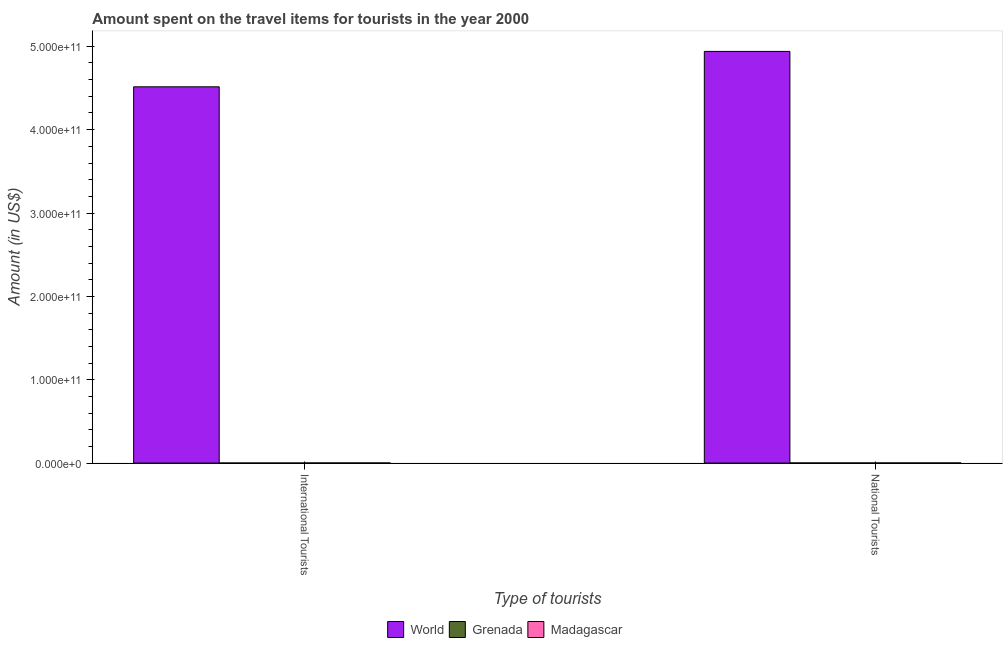How many different coloured bars are there?
Provide a succinct answer. 3. How many groups of bars are there?
Your answer should be very brief. 2. How many bars are there on the 1st tick from the right?
Your answer should be very brief. 3. What is the label of the 1st group of bars from the left?
Provide a succinct answer. International Tourists. What is the amount spent on travel items of national tourists in Grenada?
Ensure brevity in your answer.  9.30e+07. Across all countries, what is the maximum amount spent on travel items of international tourists?
Make the answer very short. 4.51e+11. Across all countries, what is the minimum amount spent on travel items of national tourists?
Ensure brevity in your answer.  9.30e+07. In which country was the amount spent on travel items of international tourists maximum?
Your answer should be very brief. World. In which country was the amount spent on travel items of international tourists minimum?
Give a very brief answer. Grenada. What is the total amount spent on travel items of international tourists in the graph?
Provide a short and direct response. 4.52e+11. What is the difference between the amount spent on travel items of international tourists in World and that in Madagascar?
Offer a terse response. 4.51e+11. What is the difference between the amount spent on travel items of national tourists in Madagascar and the amount spent on travel items of international tourists in World?
Your answer should be very brief. -4.51e+11. What is the average amount spent on travel items of international tourists per country?
Provide a short and direct response. 1.51e+11. What is the difference between the amount spent on travel items of national tourists and amount spent on travel items of international tourists in Grenada?
Make the answer very short. 8.50e+07. In how many countries, is the amount spent on travel items of international tourists greater than 440000000000 US$?
Provide a succinct answer. 1. What is the ratio of the amount spent on travel items of international tourists in Grenada to that in World?
Ensure brevity in your answer.  1.772176622460758e-5. Is the amount spent on travel items of national tourists in World less than that in Madagascar?
Provide a succinct answer. No. What does the 1st bar from the right in International Tourists represents?
Ensure brevity in your answer.  Madagascar. What is the difference between two consecutive major ticks on the Y-axis?
Make the answer very short. 1.00e+11. Does the graph contain any zero values?
Your response must be concise. No. Does the graph contain grids?
Provide a short and direct response. No. How many legend labels are there?
Offer a terse response. 3. How are the legend labels stacked?
Make the answer very short. Horizontal. What is the title of the graph?
Provide a succinct answer. Amount spent on the travel items for tourists in the year 2000. Does "Other small states" appear as one of the legend labels in the graph?
Offer a very short reply. No. What is the label or title of the X-axis?
Your answer should be very brief. Type of tourists. What is the Amount (in US$) in World in International Tourists?
Your answer should be compact. 4.51e+11. What is the Amount (in US$) of Grenada in International Tourists?
Ensure brevity in your answer.  8.00e+06. What is the Amount (in US$) of Madagascar in International Tourists?
Your answer should be very brief. 1.15e+08. What is the Amount (in US$) of World in National Tourists?
Your answer should be compact. 4.94e+11. What is the Amount (in US$) of Grenada in National Tourists?
Your answer should be compact. 9.30e+07. What is the Amount (in US$) of Madagascar in National Tourists?
Give a very brief answer. 1.21e+08. Across all Type of tourists, what is the maximum Amount (in US$) of World?
Provide a succinct answer. 4.94e+11. Across all Type of tourists, what is the maximum Amount (in US$) of Grenada?
Offer a terse response. 9.30e+07. Across all Type of tourists, what is the maximum Amount (in US$) in Madagascar?
Your response must be concise. 1.21e+08. Across all Type of tourists, what is the minimum Amount (in US$) of World?
Provide a succinct answer. 4.51e+11. Across all Type of tourists, what is the minimum Amount (in US$) of Grenada?
Offer a terse response. 8.00e+06. Across all Type of tourists, what is the minimum Amount (in US$) in Madagascar?
Ensure brevity in your answer.  1.15e+08. What is the total Amount (in US$) of World in the graph?
Your answer should be very brief. 9.45e+11. What is the total Amount (in US$) of Grenada in the graph?
Provide a short and direct response. 1.01e+08. What is the total Amount (in US$) in Madagascar in the graph?
Ensure brevity in your answer.  2.36e+08. What is the difference between the Amount (in US$) of World in International Tourists and that in National Tourists?
Provide a succinct answer. -4.25e+1. What is the difference between the Amount (in US$) of Grenada in International Tourists and that in National Tourists?
Make the answer very short. -8.50e+07. What is the difference between the Amount (in US$) in Madagascar in International Tourists and that in National Tourists?
Provide a short and direct response. -6.00e+06. What is the difference between the Amount (in US$) in World in International Tourists and the Amount (in US$) in Grenada in National Tourists?
Your answer should be very brief. 4.51e+11. What is the difference between the Amount (in US$) in World in International Tourists and the Amount (in US$) in Madagascar in National Tourists?
Offer a very short reply. 4.51e+11. What is the difference between the Amount (in US$) in Grenada in International Tourists and the Amount (in US$) in Madagascar in National Tourists?
Offer a very short reply. -1.13e+08. What is the average Amount (in US$) of World per Type of tourists?
Keep it short and to the point. 4.73e+11. What is the average Amount (in US$) in Grenada per Type of tourists?
Provide a short and direct response. 5.05e+07. What is the average Amount (in US$) of Madagascar per Type of tourists?
Your answer should be very brief. 1.18e+08. What is the difference between the Amount (in US$) of World and Amount (in US$) of Grenada in International Tourists?
Ensure brevity in your answer.  4.51e+11. What is the difference between the Amount (in US$) of World and Amount (in US$) of Madagascar in International Tourists?
Your response must be concise. 4.51e+11. What is the difference between the Amount (in US$) in Grenada and Amount (in US$) in Madagascar in International Tourists?
Your response must be concise. -1.07e+08. What is the difference between the Amount (in US$) in World and Amount (in US$) in Grenada in National Tourists?
Ensure brevity in your answer.  4.94e+11. What is the difference between the Amount (in US$) of World and Amount (in US$) of Madagascar in National Tourists?
Your response must be concise. 4.94e+11. What is the difference between the Amount (in US$) of Grenada and Amount (in US$) of Madagascar in National Tourists?
Provide a short and direct response. -2.80e+07. What is the ratio of the Amount (in US$) in World in International Tourists to that in National Tourists?
Your response must be concise. 0.91. What is the ratio of the Amount (in US$) of Grenada in International Tourists to that in National Tourists?
Provide a short and direct response. 0.09. What is the ratio of the Amount (in US$) of Madagascar in International Tourists to that in National Tourists?
Give a very brief answer. 0.95. What is the difference between the highest and the second highest Amount (in US$) in World?
Offer a very short reply. 4.25e+1. What is the difference between the highest and the second highest Amount (in US$) in Grenada?
Your response must be concise. 8.50e+07. What is the difference between the highest and the lowest Amount (in US$) of World?
Offer a very short reply. 4.25e+1. What is the difference between the highest and the lowest Amount (in US$) of Grenada?
Offer a terse response. 8.50e+07. What is the difference between the highest and the lowest Amount (in US$) of Madagascar?
Your answer should be compact. 6.00e+06. 